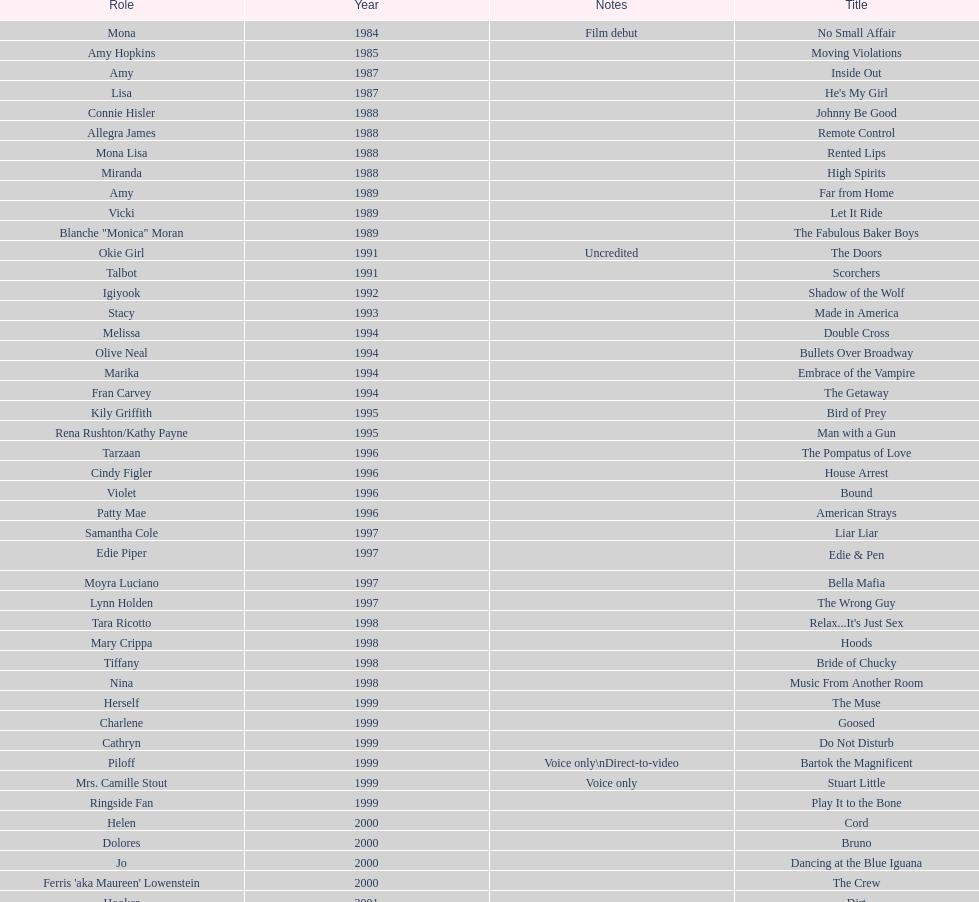How many rolls did jennifer tilly play in the 1980s? 11. 